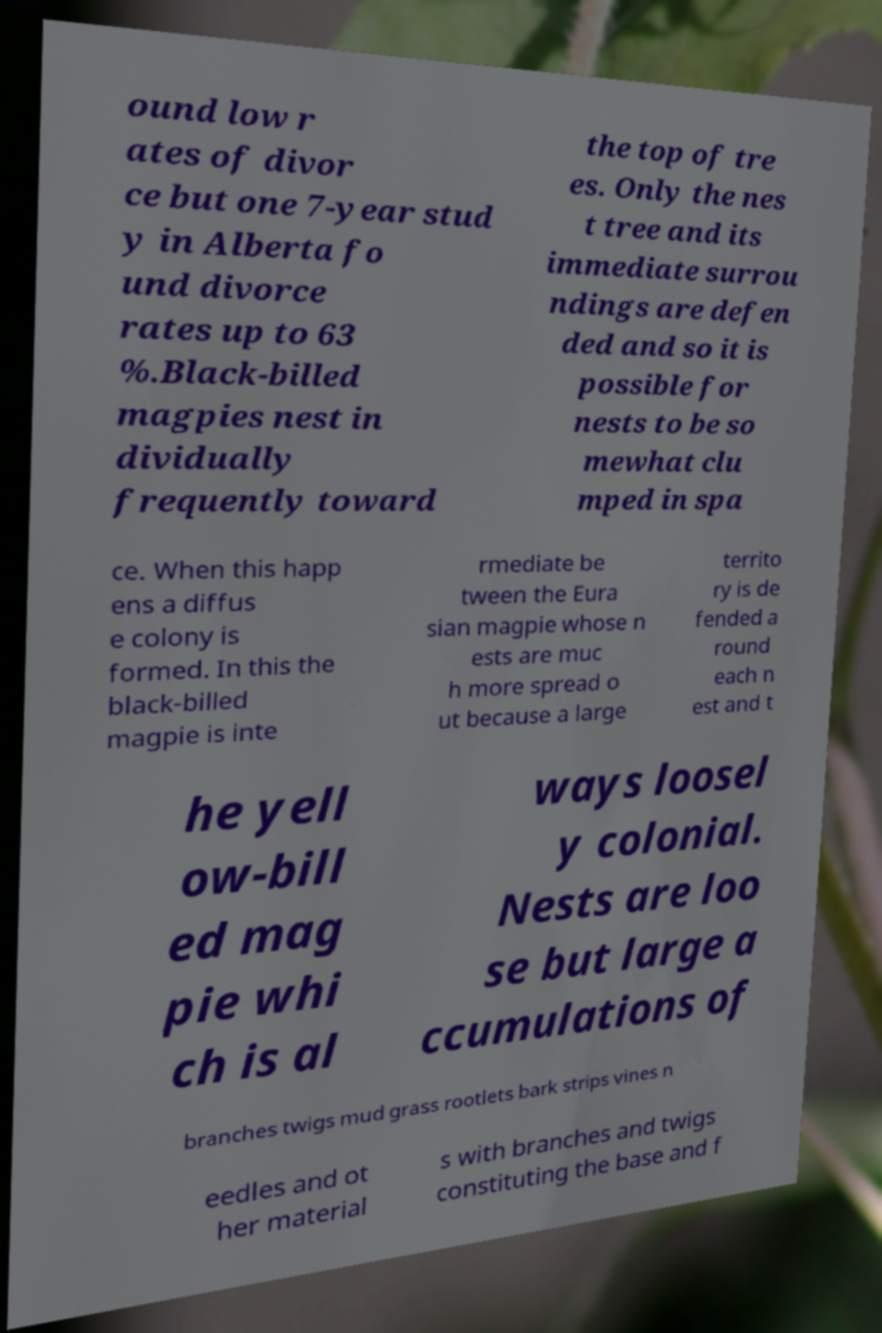For documentation purposes, I need the text within this image transcribed. Could you provide that? ound low r ates of divor ce but one 7-year stud y in Alberta fo und divorce rates up to 63 %.Black-billed magpies nest in dividually frequently toward the top of tre es. Only the nes t tree and its immediate surrou ndings are defen ded and so it is possible for nests to be so mewhat clu mped in spa ce. When this happ ens a diffus e colony is formed. In this the black-billed magpie is inte rmediate be tween the Eura sian magpie whose n ests are muc h more spread o ut because a large territo ry is de fended a round each n est and t he yell ow-bill ed mag pie whi ch is al ways loosel y colonial. Nests are loo se but large a ccumulations of branches twigs mud grass rootlets bark strips vines n eedles and ot her material s with branches and twigs constituting the base and f 